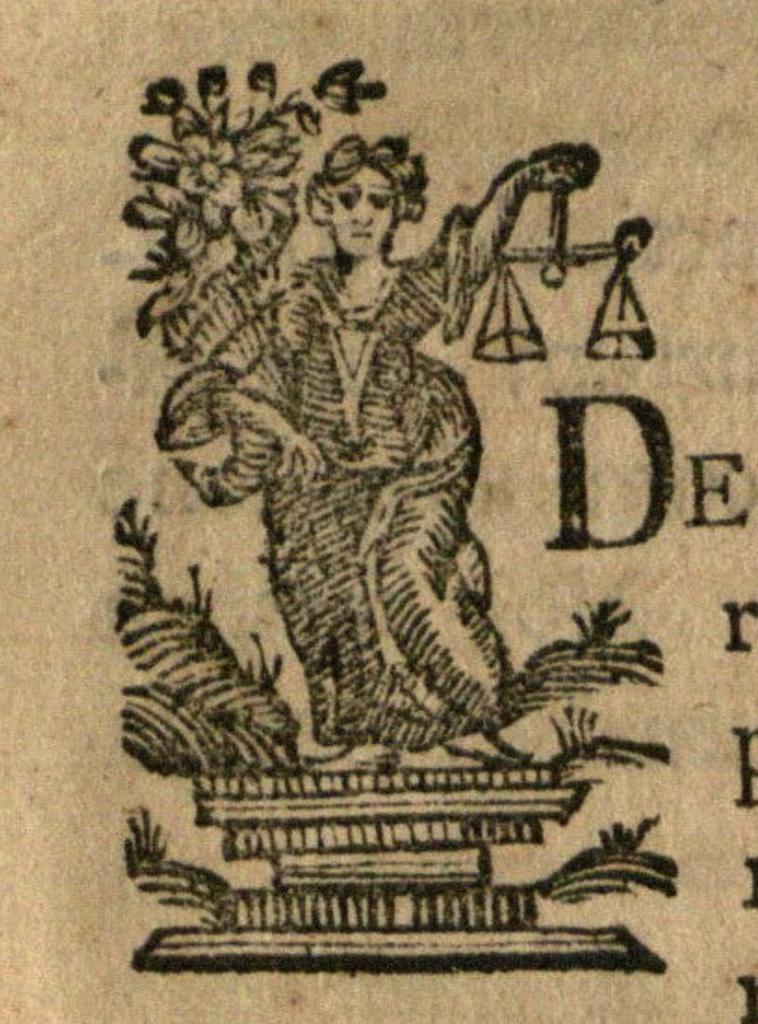<image>
Offer a succinct explanation of the picture presented. A drawing of a women standing on something with the letter D to the right 